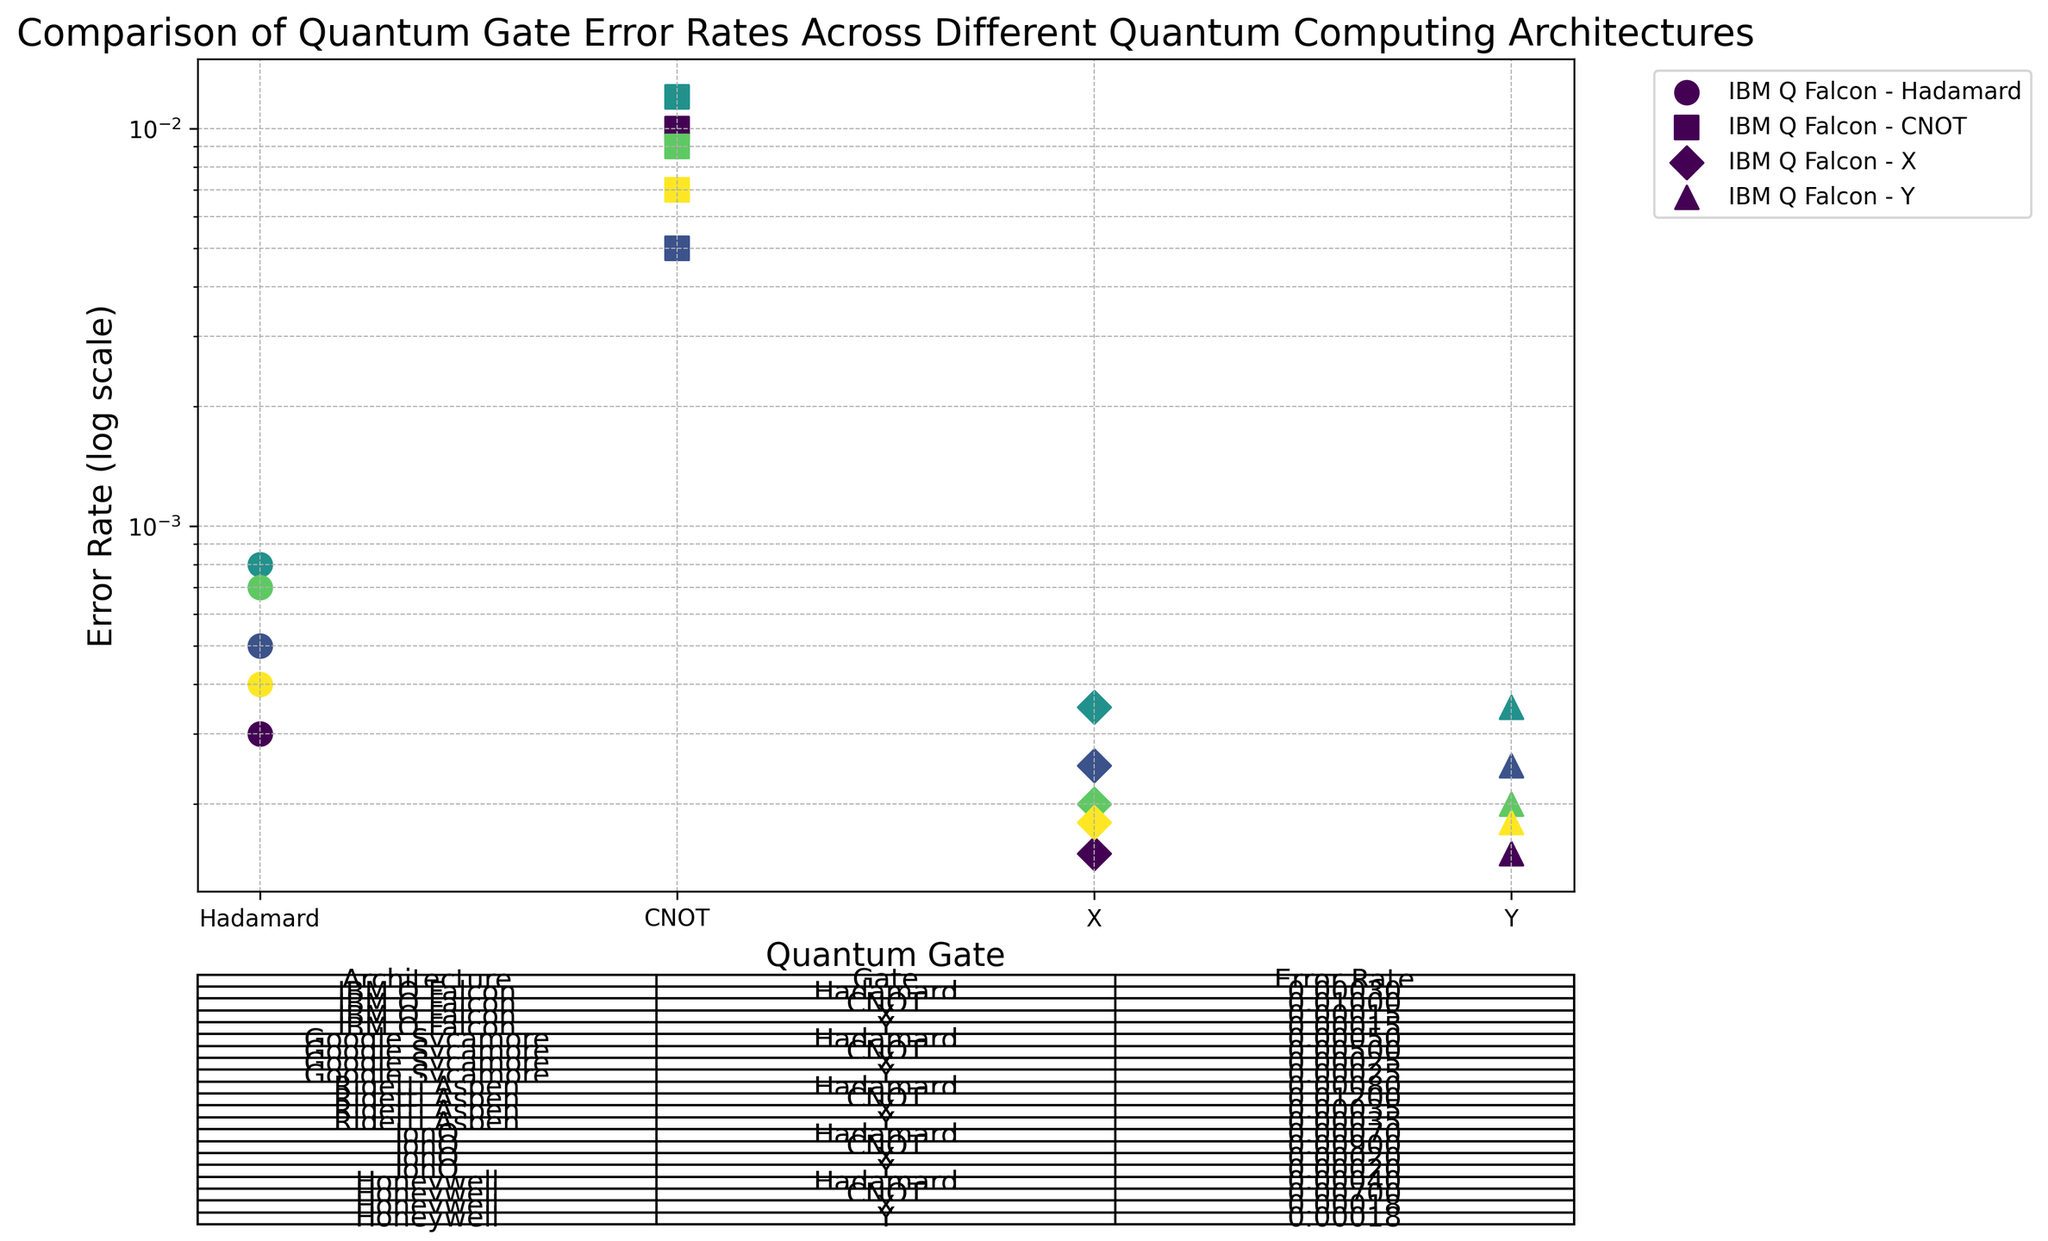Which architecture has the lowest error rate for the Hadamard gate? Examine the figure and locate the error rates for the Hadamard gate across all architectures. IBM Q Falcon has the lowest error rate at 0.0003.
Answer: IBM Q Falcon Between Google Sycamore and IonQ, which architecture has a lower error rate for the CNOT gate? Compare the CNOT gate error rates for both Google Sycamore and IonQ. Google Sycamore has a lower error rate of 0.005, whereas IonQ has 0.009.
Answer: Google Sycamore What is the average error rate for the X gate across all architectures? Identify the error rates for the X gate for all architectures (0.00015 for IBM Q Falcon, 0.00025 for Google Sycamore, 0.00035 for Rigetti Aspen, 0.00020 for IonQ, and 0.00018 for Honeywell). Compute the average as follows: (0.00015 + 0.00025 + 0.00035 + 0.00020 + 0.00018) / 5 = 0.000226.
Answer: 0.000226 Is the error rate for the Y gate in IonQ greater than that in Honeywell? Compare the error rates for the Y gate in IonQ (0.00020) and Honeywell (0.00018). IonQ has a higher error rate.
Answer: Yes Which quantum architecture has the highest error rate for any gate? Identify the highest error rates across all gates in each architecture. Rigetti Aspen has the highest error rate for the CNOT gate at 0.012.
Answer: Rigetti Aspen What is the difference in error rates for the CNOT gate between Rigetti Aspen and IBM Q Falcon? Determine the error rates for the CNOT gate in Rigetti Aspen (0.012) and IBM Q Falcon (0.010), then compute the difference (0.012 - 0.010 = 0.002).
Answer: 0.002 Sorting from lowest to highest, what are the error rates for the Hadamard gate across different architectures? List the error rates for the Hadamard gate for all architectures: IBM Q Falcon (0.0003), Google Sycamore (0.0005), Rigetti Aspen (0.0008), IonQ (0.0007), and Honeywell (0.0004). Sort these values: 0.0003, 0.0004, 0.0005, 0.0007, 0.0008.
Answer: 0.0003, 0.0004, 0.0005, 0.0007, 0.0008 Which gate-architecture combination has the overall lowest error rate in the figure? Search through the figure and identify the combination with the lowest error rate. IBM Q Falcon with the X gate has the lowest error rate at 0.00015.
Answer: IBM Q Falcon with X gate 